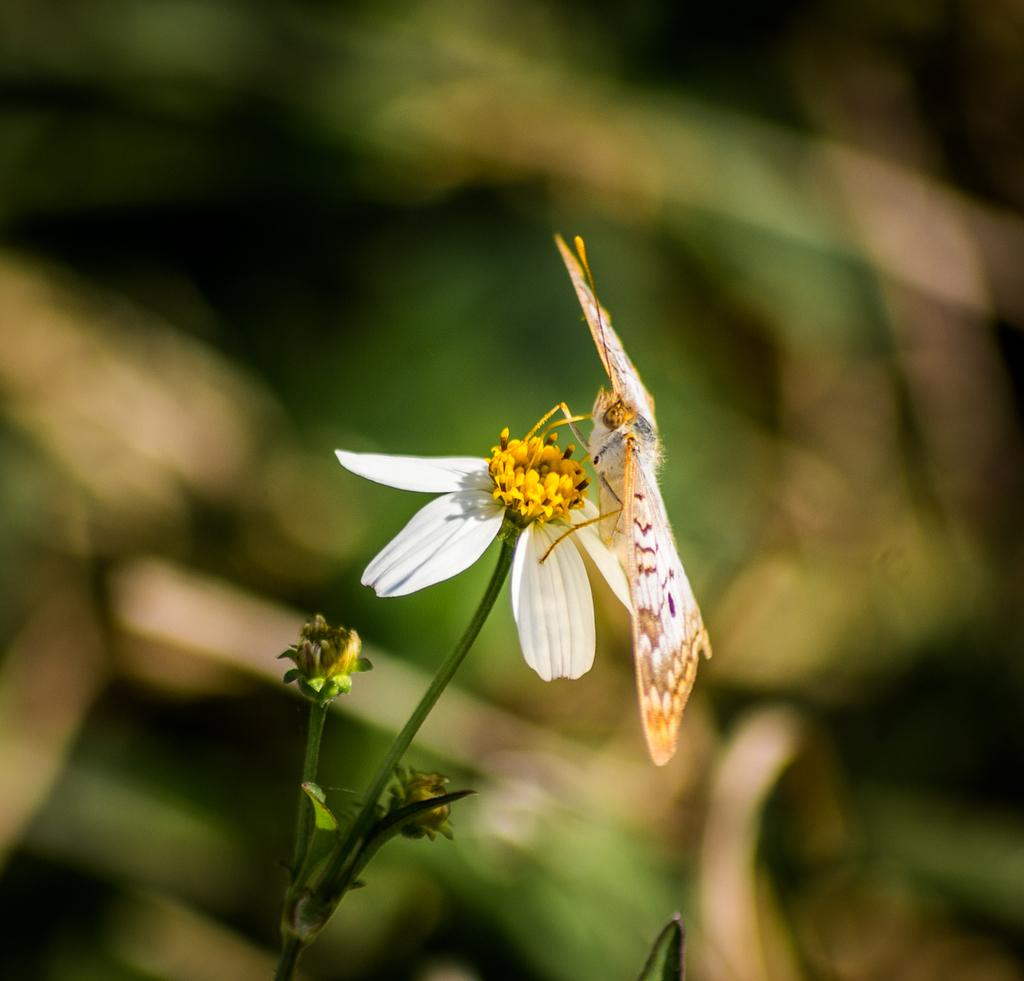What is the main subject of the image? There is a butterfly in the image. Where is the butterfly located in the image? The butterfly is on a flower. Can you describe the background of the image? The background of the image is blurred. Reasoning: Let' Let's think step by step in order to produce the conversation. We start by identifying the main subject of the image, which is the butterfly. Then, we describe the location of the butterfly, which is on a flower. Finally, we mention the background of the image, which is blurred. Each question is designed to elicit a specific detail about the image that is known from the provided facts. Absurd Question/Answer: What type of house can be seen in the background of the image? There is no house present in the image; the background is blurred. What is the friction between the butterfly and the flower in the image? The concept of friction is not applicable to the interaction between the butterfly and the flower in the image, as it is a photograph and not a physical interaction. What is the need for the butterfly to be on the flower in the image? The concept of need is not applicable to the butterfly's presence on the flower in the image, as it is a natural occurrence and not a deliberate action. 